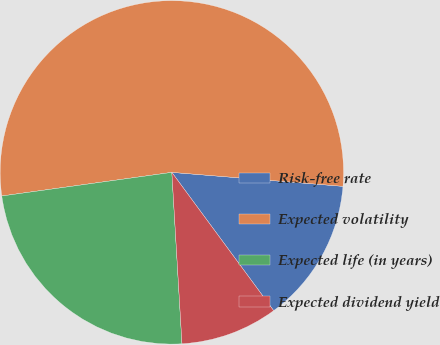Convert chart. <chart><loc_0><loc_0><loc_500><loc_500><pie_chart><fcel>Risk-free rate<fcel>Expected volatility<fcel>Expected life (in years)<fcel>Expected dividend yield<nl><fcel>13.6%<fcel>53.49%<fcel>23.74%<fcel>9.16%<nl></chart> 